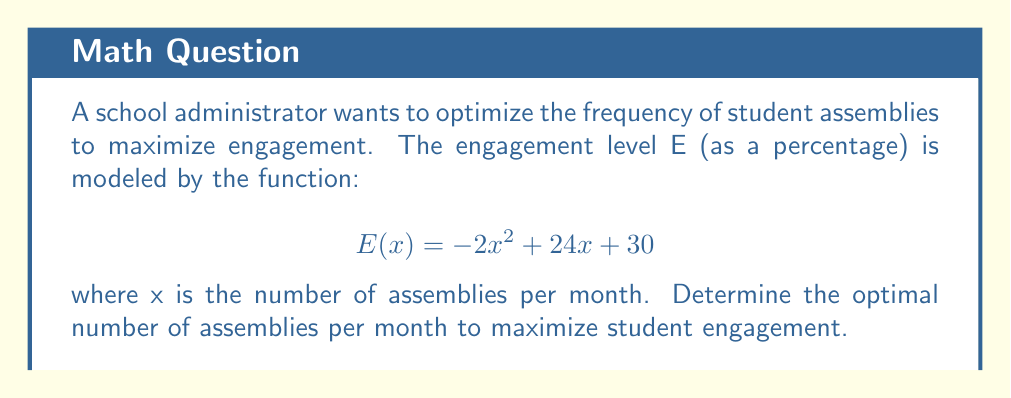Provide a solution to this math problem. To find the optimal number of assemblies, we need to find the maximum of the function E(x). This can be done by finding the x-coordinate of the vertex of the parabola.

Step 1: Find the derivative of E(x).
$$E'(x) = -4x + 24$$

Step 2: Set the derivative equal to zero and solve for x.
$$-4x + 24 = 0$$
$$-4x = -24$$
$$x = 6$$

Step 3: Verify that this is a maximum by checking the second derivative.
$$E''(x) = -4$$
Since E''(x) is negative, the critical point is a maximum.

Step 4: Check the domain constraints.
Since x represents the number of assemblies per month, it must be a non-negative integer. The closest integer to 6 that maximizes the function is 6 itself.

Therefore, the optimal number of assemblies per month is 6.
Answer: 6 assemblies per month 